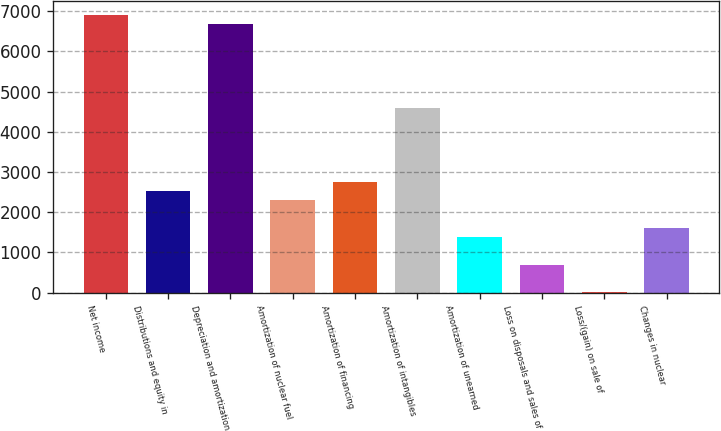Convert chart. <chart><loc_0><loc_0><loc_500><loc_500><bar_chart><fcel>Net income<fcel>Distributions and equity in<fcel>Depreciation and amortization<fcel>Amortization of nuclear fuel<fcel>Amortization of financing<fcel>Amortization of intangibles<fcel>Amortization of unearned<fcel>Loss on disposals and sales of<fcel>Loss/(gain) on sale of<fcel>Changes in nuclear<nl><fcel>6904<fcel>2534<fcel>6674<fcel>2304<fcel>2764<fcel>4604<fcel>1384<fcel>694<fcel>4<fcel>1614<nl></chart> 